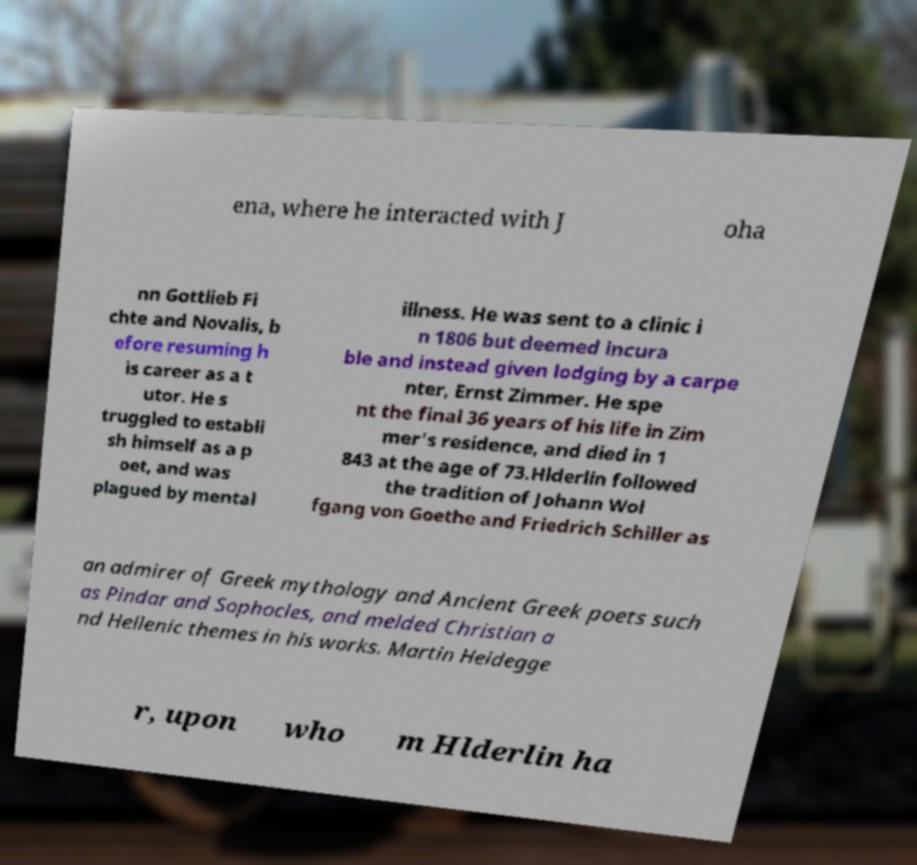Please identify and transcribe the text found in this image. ena, where he interacted with J oha nn Gottlieb Fi chte and Novalis, b efore resuming h is career as a t utor. He s truggled to establi sh himself as a p oet, and was plagued by mental illness. He was sent to a clinic i n 1806 but deemed incura ble and instead given lodging by a carpe nter, Ernst Zimmer. He spe nt the final 36 years of his life in Zim mer's residence, and died in 1 843 at the age of 73.Hlderlin followed the tradition of Johann Wol fgang von Goethe and Friedrich Schiller as an admirer of Greek mythology and Ancient Greek poets such as Pindar and Sophocles, and melded Christian a nd Hellenic themes in his works. Martin Heidegge r, upon who m Hlderlin ha 